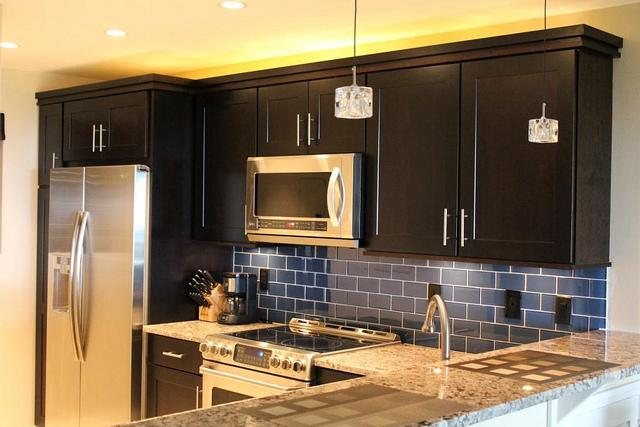What does the item with silver doors regulate? temperature 